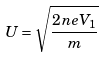Convert formula to latex. <formula><loc_0><loc_0><loc_500><loc_500>U = \sqrt { \frac { 2 n e V _ { 1 } } { m } }</formula> 